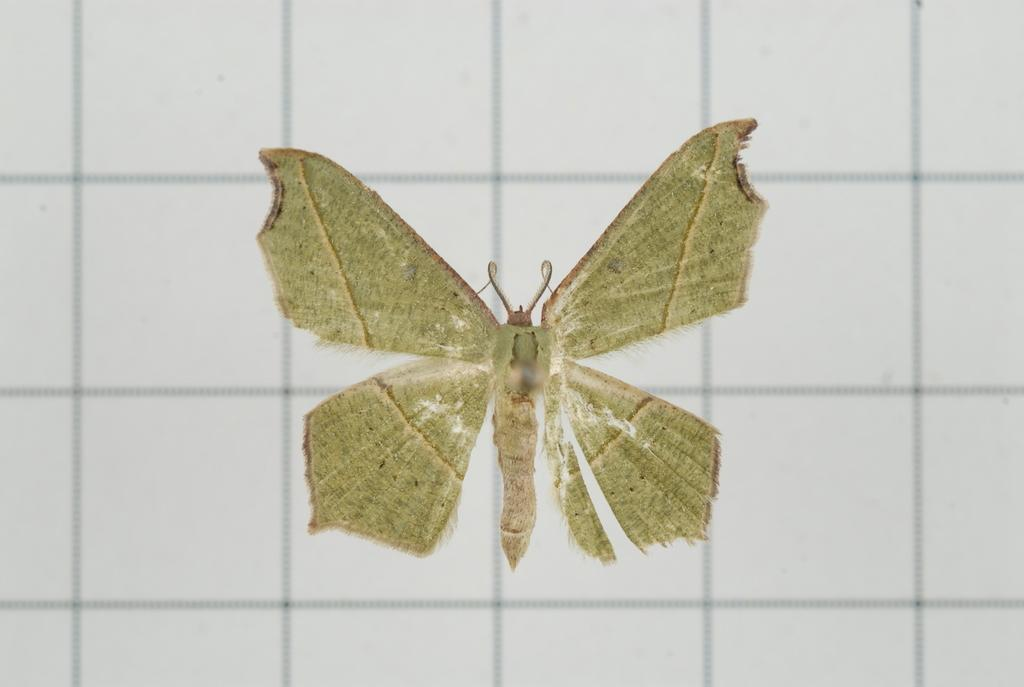What type of background can be seen in the image? There are wall tiles visible in the background of the image. What living creature is present in the image? There is a butterfly in the image. What type of slope can be seen in the image? There is no slope present in the image; it features wall tiles and a butterfly. What color is the crayon used to draw the butterfly in the image? There is no crayon or drawing in the image; it is a photograph of a real butterfly. 